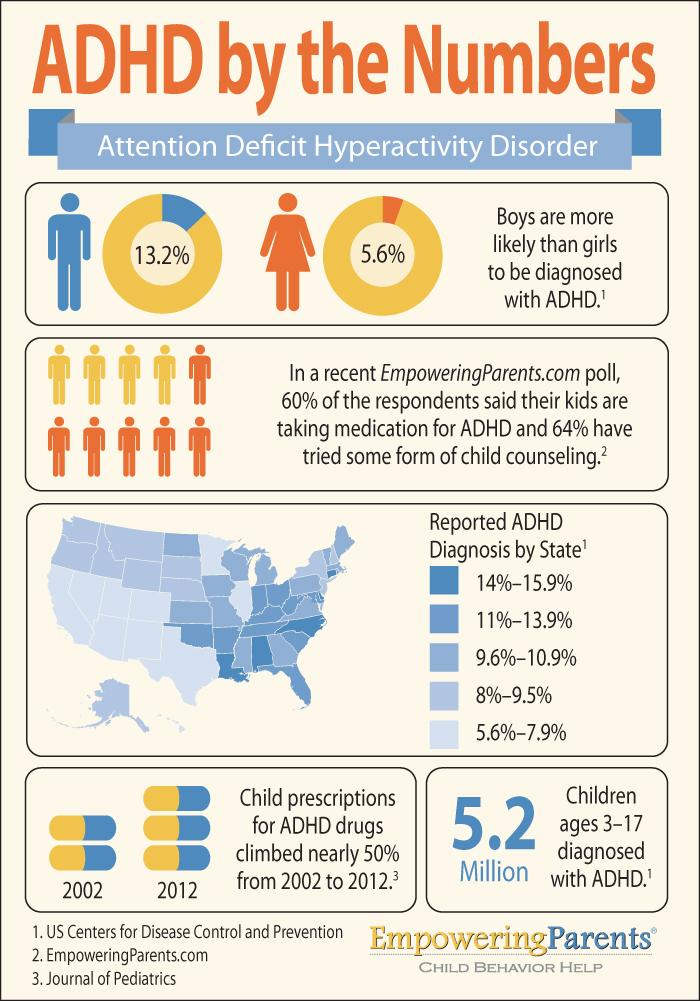Indicate a few pertinent items in this graphic. The female icon is orange in color. In 2002, the number of prescriptions for ADHD medication for children was significantly reduced by almost 50%. There are three sources listed in total. 